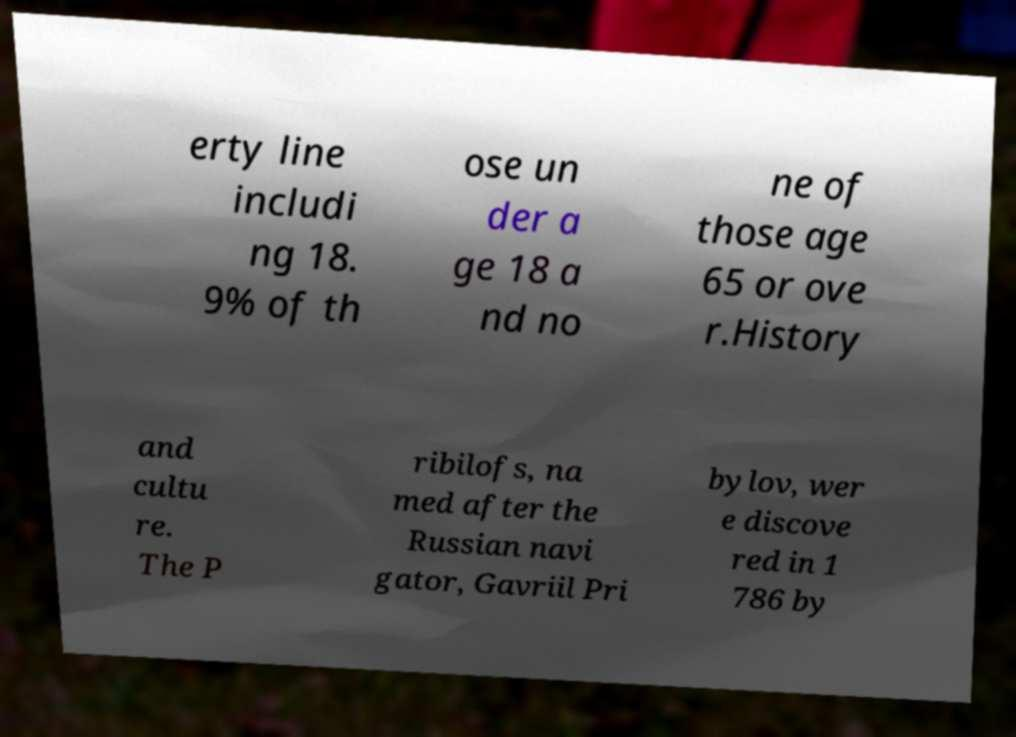What messages or text are displayed in this image? I need them in a readable, typed format. erty line includi ng 18. 9% of th ose un der a ge 18 a nd no ne of those age 65 or ove r.History and cultu re. The P ribilofs, na med after the Russian navi gator, Gavriil Pri bylov, wer e discove red in 1 786 by 